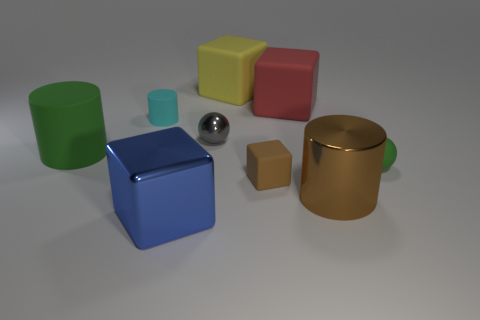There is a small object that is the same color as the large metallic cylinder; what is it made of?
Offer a terse response. Rubber. What number of other objects are there of the same material as the cyan cylinder?
Provide a succinct answer. 5. What shape is the large thing that is left of the big yellow thing and behind the tiny brown object?
Keep it short and to the point. Cylinder. There is a big cylinder that is made of the same material as the large red thing; what is its color?
Make the answer very short. Green. Are there the same number of red objects that are left of the blue shiny object and tiny rubber cylinders?
Your answer should be very brief. No. There is a green object that is the same size as the blue object; what shape is it?
Keep it short and to the point. Cylinder. How many other things are there of the same shape as the large green rubber object?
Your answer should be compact. 2. There is a green cylinder; is it the same size as the red cube that is behind the green sphere?
Offer a terse response. Yes. What number of things are tiny objects that are behind the rubber sphere or big brown shiny cylinders?
Offer a terse response. 3. What is the shape of the big shiny thing that is in front of the brown shiny cylinder?
Offer a very short reply. Cube. 